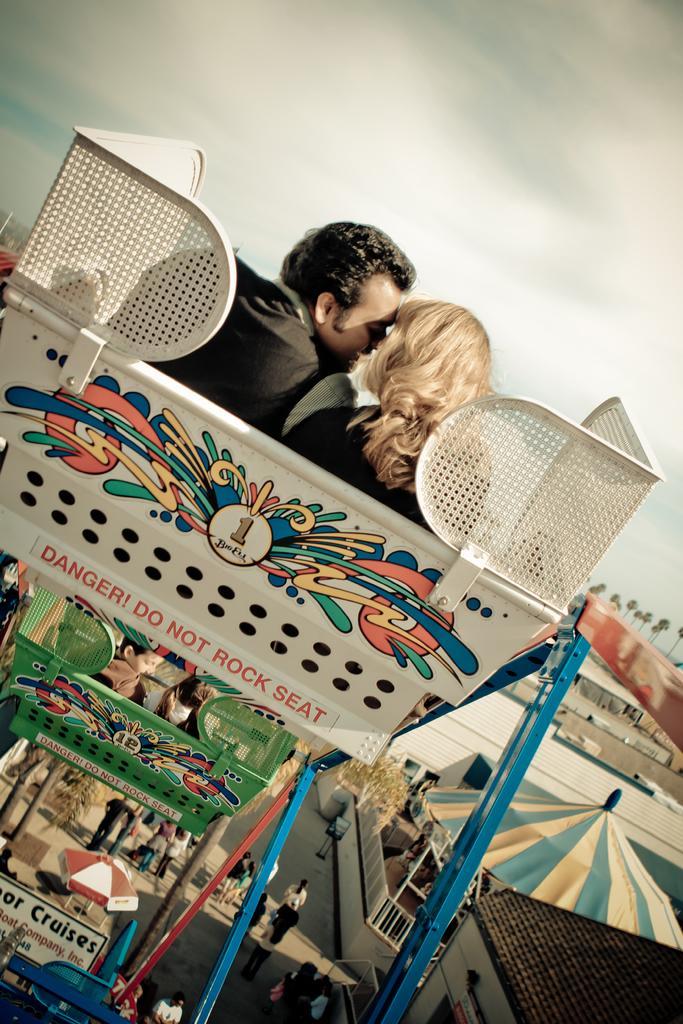In one or two sentences, can you explain what this image depicts? In the foreground of the image we can see two people sitting on a ride. To the right side of the image there are houses, trees. At the top of the image there is sky. At the bottom of the image there are people walking on the road. 